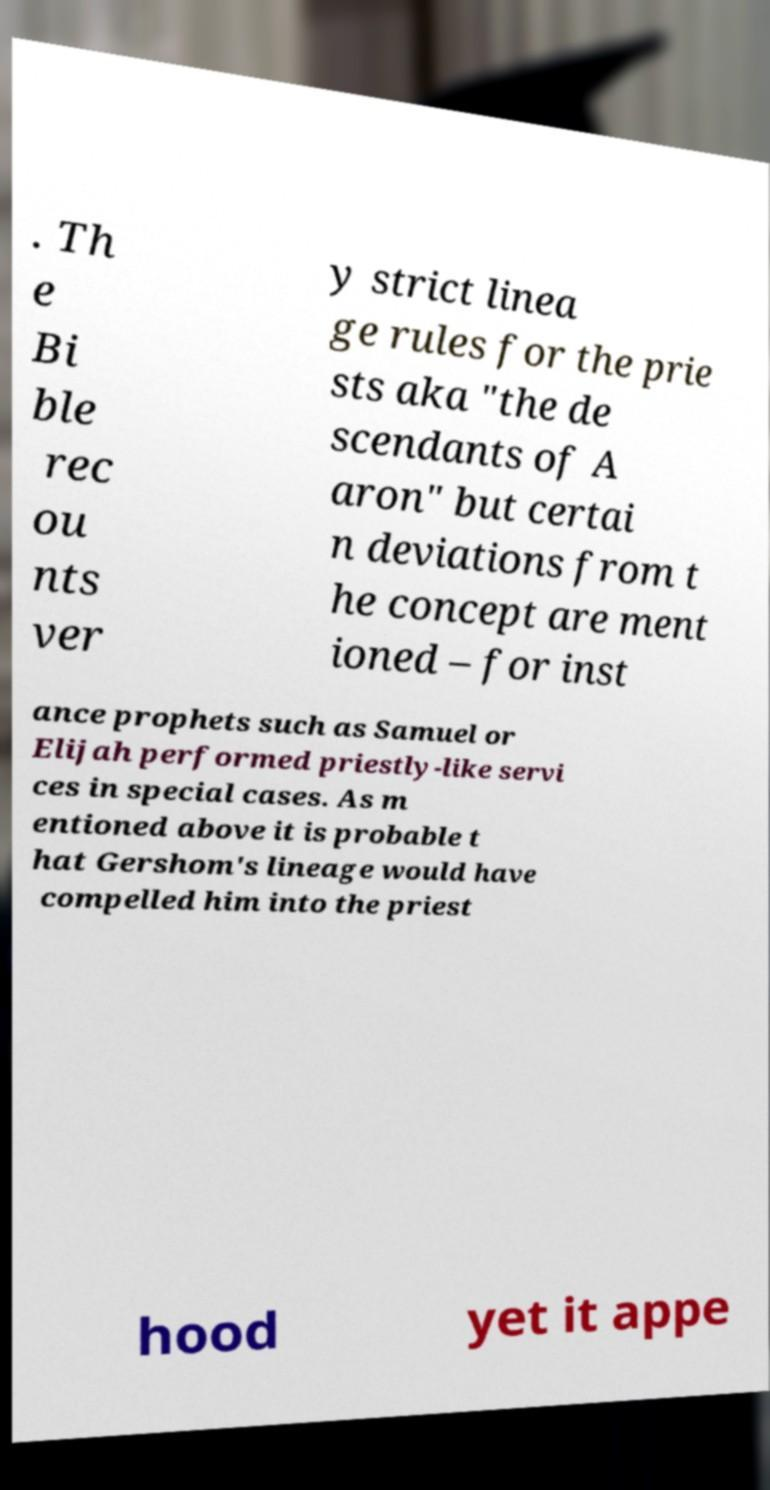For documentation purposes, I need the text within this image transcribed. Could you provide that? . Th e Bi ble rec ou nts ver y strict linea ge rules for the prie sts aka "the de scendants of A aron" but certai n deviations from t he concept are ment ioned – for inst ance prophets such as Samuel or Elijah performed priestly-like servi ces in special cases. As m entioned above it is probable t hat Gershom's lineage would have compelled him into the priest hood yet it appe 